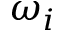Convert formula to latex. <formula><loc_0><loc_0><loc_500><loc_500>\omega _ { i }</formula> 